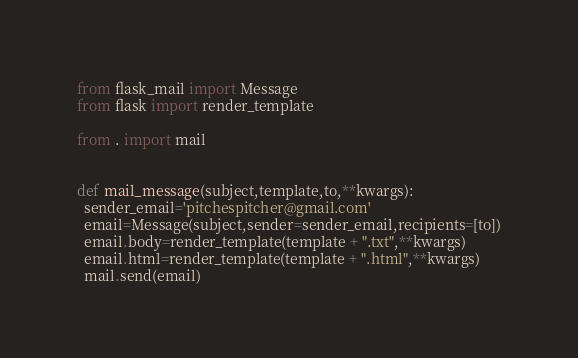Convert code to text. <code><loc_0><loc_0><loc_500><loc_500><_Python_>from flask_mail import Message
from flask import render_template

from . import mail


def mail_message(subject,template,to,**kwargs):
  sender_email='pitchespitcher@gmail.com'
  email=Message(subject,sender=sender_email,recipients=[to])
  email.body=render_template(template + ".txt",**kwargs)
  email.html=render_template(template + ".html",**kwargs)
  mail.send(email)</code> 